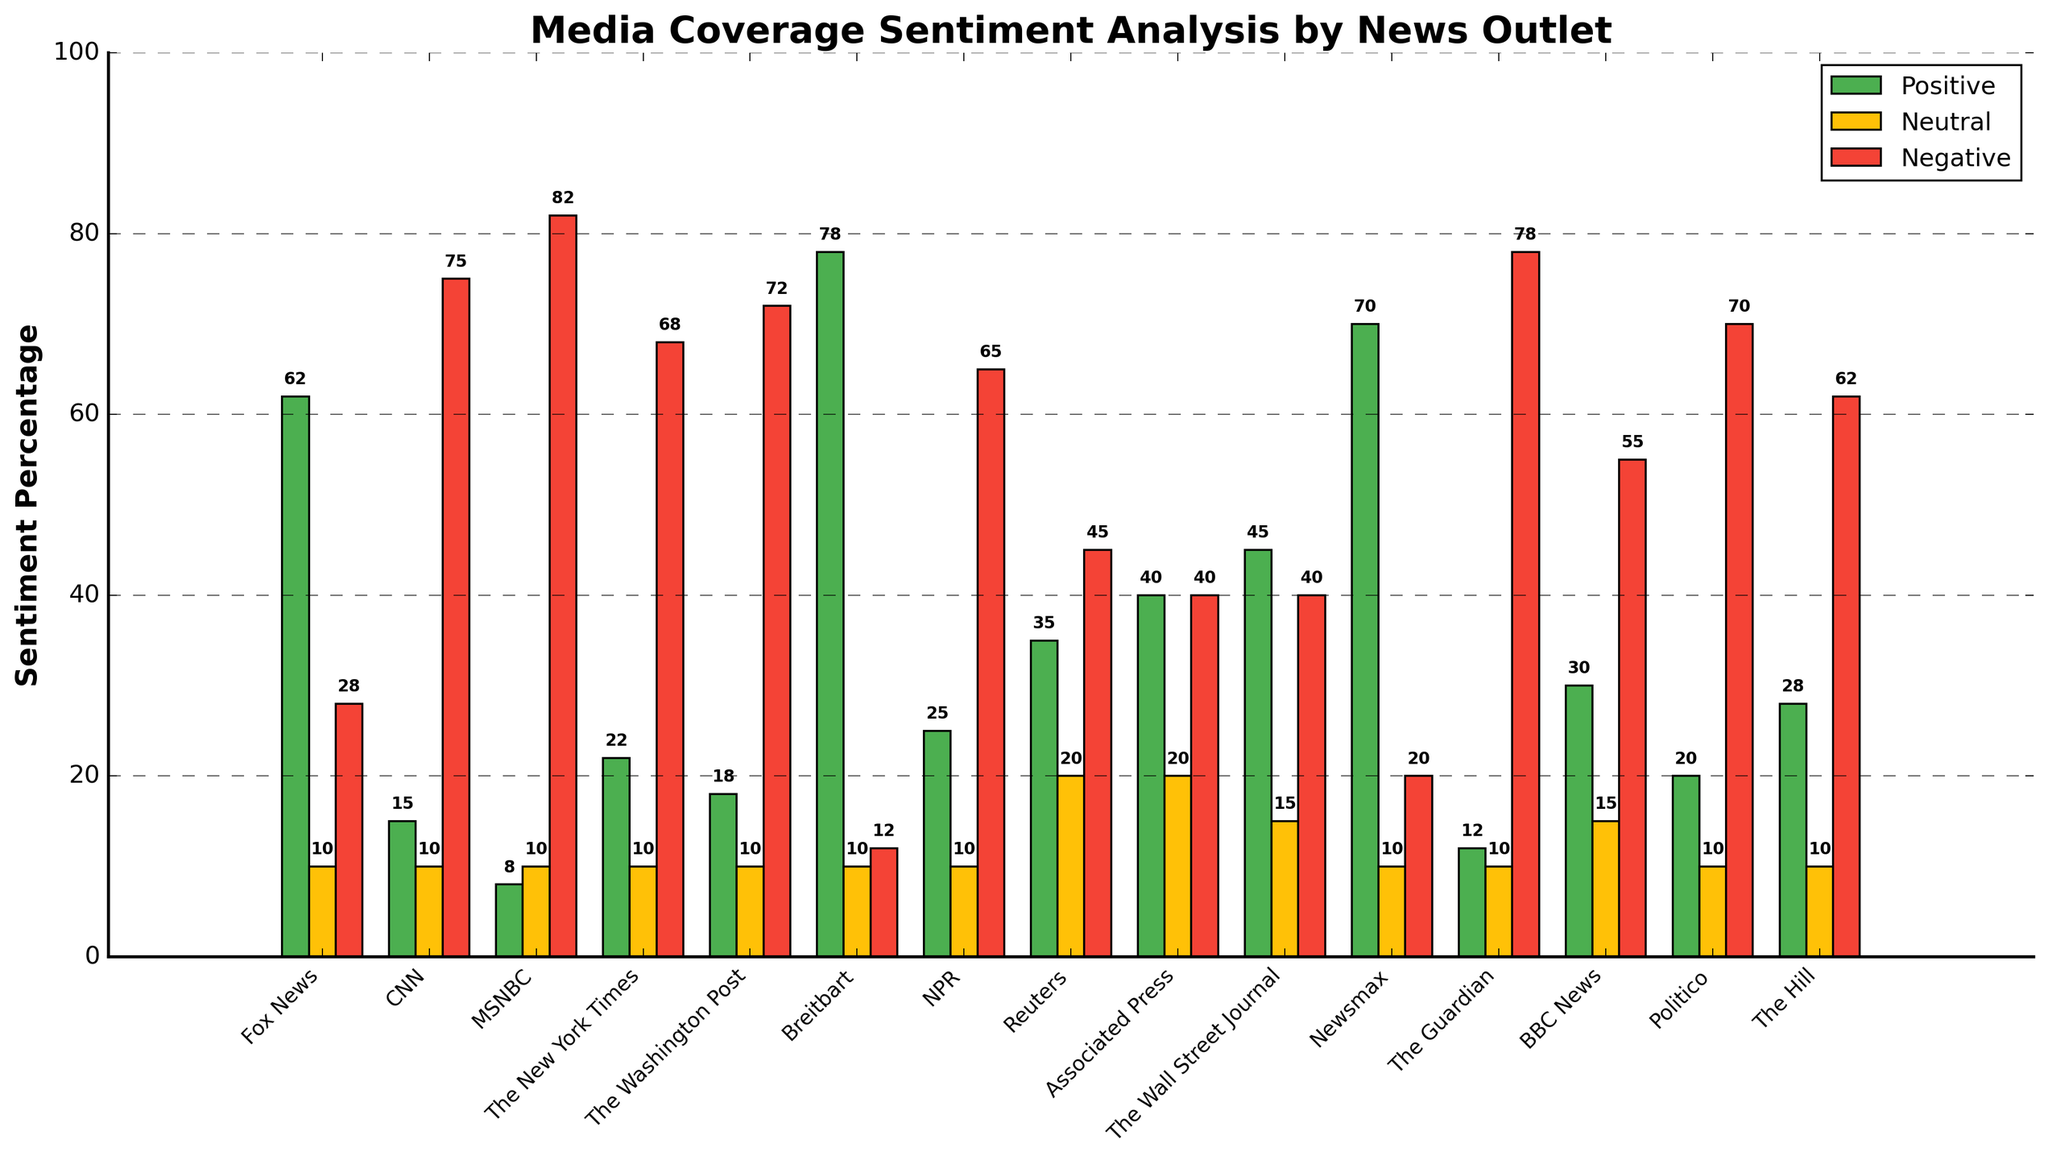Which news outlet has the highest positive sentiment percentage? By observing the height of the green bars, it is clear that Breitbart has the highest positive sentiment percentage.
Answer: Breitbart Which three news outlets have the equal percentage for neutral sentiment? By examining the yellow bars, it can be seen that Fox News, CNN, MSNBC, The New York Times, The Washington Post, Breitbart, NPR, Newsmax, The Guardian, and The Hill all have a neutral sentiment percentage of 10%.
Answer: Fox News, CNN, MSNBC, The New York Times, The Washington Post, Breitbart, NPR, Newsmax, The Guardian, The Hill Between Fox News and CNN, which has a lower negative sentiment percentage? By comparing the heights of the red bars for Fox News and CNN, Fox News has a lower negative sentiment percentage of 28% compared to CNN's 75%.
Answer: Fox News Which outlet has the highest negative sentiment percentage? By identifying the tallest red bar, MSNBC has the highest negative sentiment percentage with 82%.
Answer: MSNBC What is the combined positive sentiment percentage for NPR and Reuters? Adding the positive sentiment percentages for NPR (25%) and Reuters (35%) gives a total of 60%.
Answer: 60% Which news outlet has the highest neutral sentiment percentage, and what is it? Observing the heights of the yellow bars, Reuters and Associated Press both have the highest neutral sentiment percentage, which is 20%.
Answer: Reuters and Associated Press How many news outlets have a negative sentiment percentage of 70% or higher? By counting the red bars with heights of 70% or more, there are four such outlets: CNN (75%), MSNBC (82%), The Washington Post (72%), and Politico (70%).
Answer: 4 What is the average positive sentiment percentage among all news outlets shown? Summing the positive sentiment percentages (62+15+8+22+18+78+25+35+40+45+70+12+30+20+28) and dividing by the number of outlets (15) yields an average of approximately 33.
Answer: 33 Which news outlet has the most evenly distributed sentiment percentages? Comparing the heights of all three bars (green, yellow, red) for each outlet, Associated Press and The Wall Street Journal have the most evenly distributed percentages with 40% positive, 40% neutral, 20% neutral, and 45% positive, 40% neutral, and 15% negative, respectively.
Answer: Associated Press and The Wall Street Journal What is the difference in neutral sentiment percentage between Reuters and The Guardian? Subtracting The Guardian's neutral sentiment percentage (10%) from Reuters' neutral sentiment percentage (20%) gives a difference of 10%.
Answer: 10% 